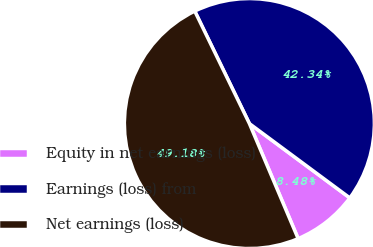Convert chart to OTSL. <chart><loc_0><loc_0><loc_500><loc_500><pie_chart><fcel>Equity in net earnings (loss)<fcel>Earnings (loss) from<fcel>Net earnings (loss)<nl><fcel>8.48%<fcel>42.34%<fcel>49.18%<nl></chart> 